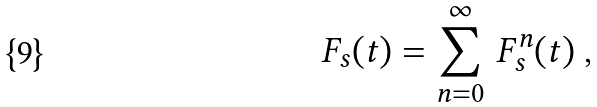Convert formula to latex. <formula><loc_0><loc_0><loc_500><loc_500>F _ { s } ( t ) = \sum ^ { \infty } _ { n = 0 } \, F ^ { n } _ { s } ( t ) \ ,</formula> 